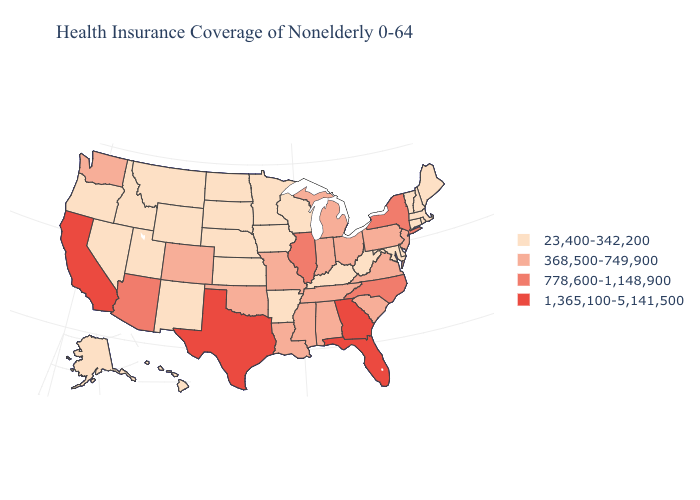Which states hav the highest value in the West?
Concise answer only. California. Name the states that have a value in the range 778,600-1,148,900?
Be succinct. Arizona, Illinois, New York, North Carolina. Does New Jersey have the lowest value in the USA?
Short answer required. No. Does Ohio have a higher value than North Carolina?
Write a very short answer. No. Name the states that have a value in the range 778,600-1,148,900?
Short answer required. Arizona, Illinois, New York, North Carolina. What is the value of Hawaii?
Keep it brief. 23,400-342,200. What is the value of Nebraska?
Be succinct. 23,400-342,200. Name the states that have a value in the range 778,600-1,148,900?
Concise answer only. Arizona, Illinois, New York, North Carolina. Among the states that border Iowa , which have the lowest value?
Short answer required. Minnesota, Nebraska, South Dakota, Wisconsin. Does California have the highest value in the USA?
Short answer required. Yes. Name the states that have a value in the range 23,400-342,200?
Concise answer only. Alaska, Arkansas, Connecticut, Delaware, Hawaii, Idaho, Iowa, Kansas, Kentucky, Maine, Maryland, Massachusetts, Minnesota, Montana, Nebraska, Nevada, New Hampshire, New Mexico, North Dakota, Oregon, Rhode Island, South Dakota, Utah, Vermont, West Virginia, Wisconsin, Wyoming. Name the states that have a value in the range 23,400-342,200?
Keep it brief. Alaska, Arkansas, Connecticut, Delaware, Hawaii, Idaho, Iowa, Kansas, Kentucky, Maine, Maryland, Massachusetts, Minnesota, Montana, Nebraska, Nevada, New Hampshire, New Mexico, North Dakota, Oregon, Rhode Island, South Dakota, Utah, Vermont, West Virginia, Wisconsin, Wyoming. What is the value of Arkansas?
Give a very brief answer. 23,400-342,200. 